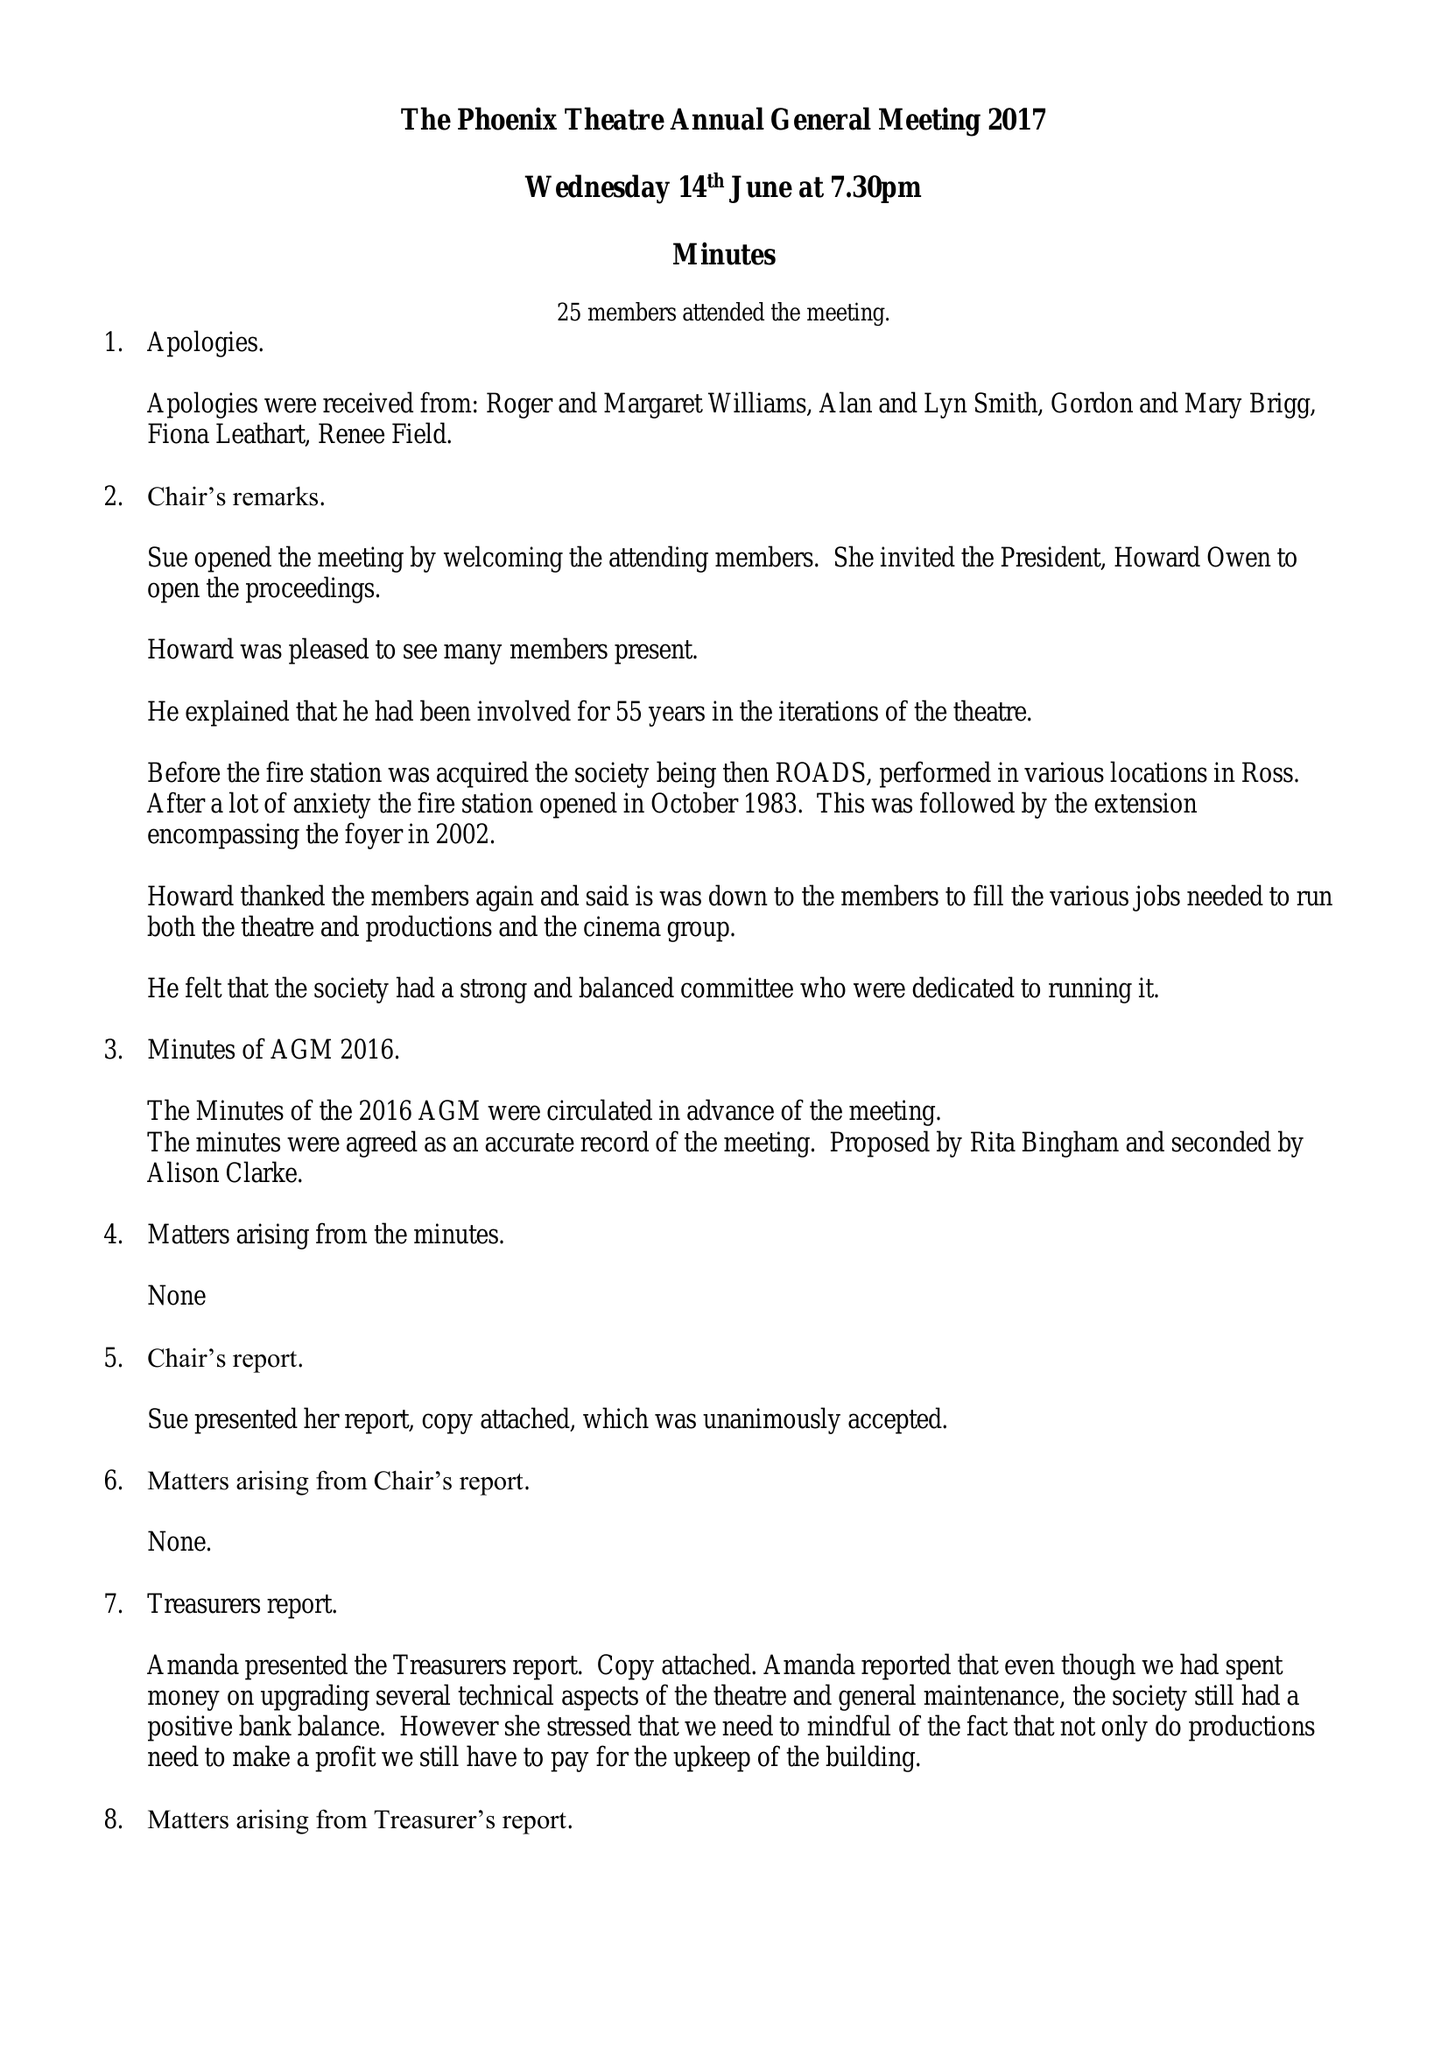What is the value for the charity_number?
Answer the question using a single word or phrase. 508668 